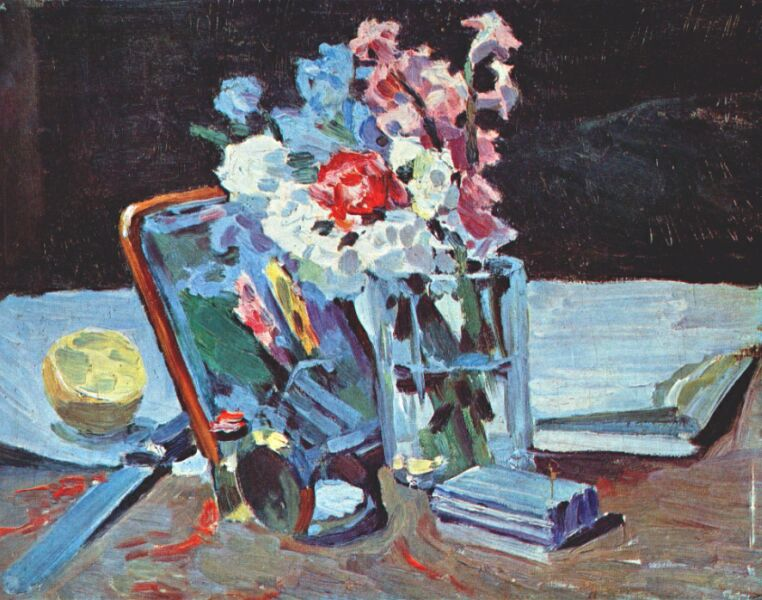Could the colors in the image symbolize anything specific? Colors often carry symbolic meanings, and in this image, the interplay of colors may be quite significant. The bold red might symbolize passion or vitality, which is emphasized by its central placement within the cluster of flowers. Whites often represent purity or simplicity and could underscore the straightforward beauty of the natural world. The blues, used in the books and subtly in the shadows, might evoke a sense of calm and scholarly thought. The juxtaposition of these colors against the dark background could reflect the spectrum of human experience, contrasting the vibrance of life and its activities with the unknown or the undefined territories of the backdrop. 